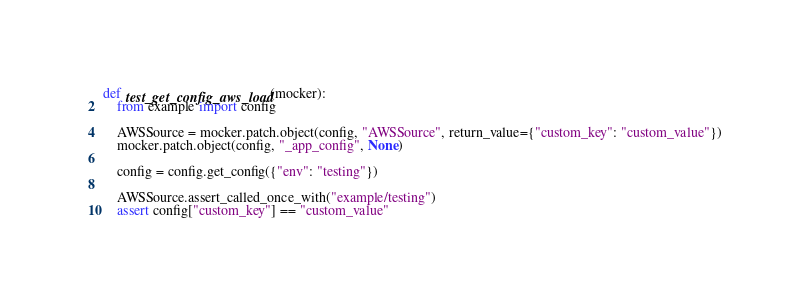Convert code to text. <code><loc_0><loc_0><loc_500><loc_500><_Python_>def test_get_config_aws_load(mocker):
    from example import config

    AWSSource = mocker.patch.object(config, "AWSSource", return_value={"custom_key": "custom_value"})
    mocker.patch.object(config, "_app_config", None)

    config = config.get_config({"env": "testing"})

    AWSSource.assert_called_once_with("example/testing")
    assert config["custom_key"] == "custom_value"
</code> 